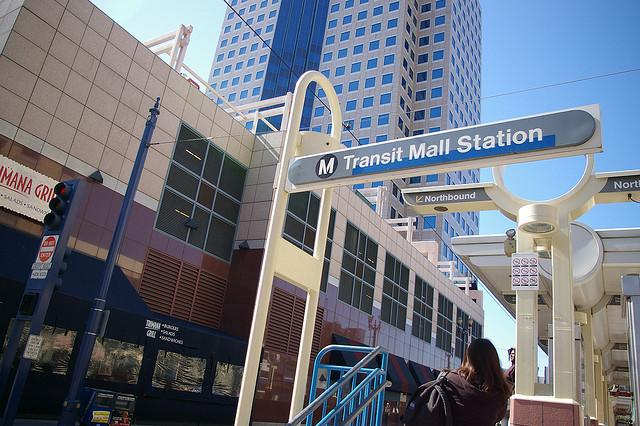What color is the light all the way to the left?

Choices:
A) blue
B) green
C) yellow
D) red red 